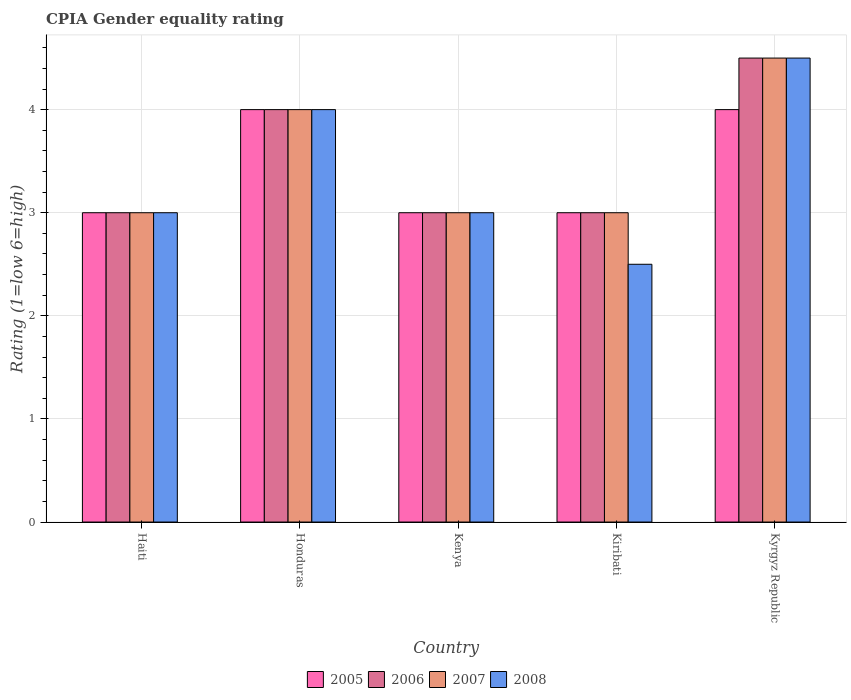Are the number of bars on each tick of the X-axis equal?
Your answer should be very brief. Yes. How many bars are there on the 2nd tick from the right?
Your answer should be very brief. 4. What is the label of the 4th group of bars from the left?
Your answer should be very brief. Kiribati. In how many cases, is the number of bars for a given country not equal to the number of legend labels?
Make the answer very short. 0. Across all countries, what is the maximum CPIA rating in 2006?
Offer a very short reply. 4.5. In which country was the CPIA rating in 2005 maximum?
Offer a very short reply. Honduras. In which country was the CPIA rating in 2008 minimum?
Your response must be concise. Kiribati. What is the difference between the CPIA rating in 2008 in Honduras and that in Kenya?
Make the answer very short. 1. In how many countries, is the CPIA rating in 2008 greater than 2?
Offer a terse response. 5. What is the ratio of the CPIA rating in 2007 in Kenya to that in Kyrgyz Republic?
Provide a succinct answer. 0.67. Is the CPIA rating in 2005 in Kenya less than that in Kyrgyz Republic?
Offer a very short reply. Yes. Is the difference between the CPIA rating in 2007 in Kenya and Kyrgyz Republic greater than the difference between the CPIA rating in 2005 in Kenya and Kyrgyz Republic?
Offer a terse response. No. What does the 2nd bar from the left in Kiribati represents?
Offer a terse response. 2006. What does the 1st bar from the right in Kiribati represents?
Offer a very short reply. 2008. Is it the case that in every country, the sum of the CPIA rating in 2007 and CPIA rating in 2008 is greater than the CPIA rating in 2006?
Your answer should be very brief. Yes. How many bars are there?
Your answer should be very brief. 20. Are all the bars in the graph horizontal?
Ensure brevity in your answer.  No. How many countries are there in the graph?
Offer a terse response. 5. Are the values on the major ticks of Y-axis written in scientific E-notation?
Offer a terse response. No. Does the graph contain any zero values?
Give a very brief answer. No. Does the graph contain grids?
Make the answer very short. Yes. Where does the legend appear in the graph?
Ensure brevity in your answer.  Bottom center. How are the legend labels stacked?
Make the answer very short. Horizontal. What is the title of the graph?
Make the answer very short. CPIA Gender equality rating. What is the label or title of the X-axis?
Make the answer very short. Country. What is the Rating (1=low 6=high) in 2005 in Haiti?
Your answer should be compact. 3. What is the Rating (1=low 6=high) of 2006 in Haiti?
Make the answer very short. 3. What is the Rating (1=low 6=high) of 2007 in Haiti?
Offer a very short reply. 3. What is the Rating (1=low 6=high) in 2008 in Haiti?
Ensure brevity in your answer.  3. What is the Rating (1=low 6=high) of 2005 in Honduras?
Give a very brief answer. 4. What is the Rating (1=low 6=high) of 2006 in Honduras?
Your response must be concise. 4. What is the Rating (1=low 6=high) of 2007 in Honduras?
Ensure brevity in your answer.  4. What is the Rating (1=low 6=high) of 2005 in Kenya?
Your answer should be compact. 3. What is the Rating (1=low 6=high) of 2008 in Kenya?
Your answer should be very brief. 3. What is the Rating (1=low 6=high) in 2006 in Kiribati?
Give a very brief answer. 3. What is the Rating (1=low 6=high) in 2008 in Kiribati?
Offer a terse response. 2.5. What is the Rating (1=low 6=high) in 2007 in Kyrgyz Republic?
Your answer should be very brief. 4.5. What is the Rating (1=low 6=high) of 2008 in Kyrgyz Republic?
Offer a terse response. 4.5. Across all countries, what is the maximum Rating (1=low 6=high) in 2005?
Provide a short and direct response. 4. Across all countries, what is the maximum Rating (1=low 6=high) in 2007?
Your answer should be compact. 4.5. Across all countries, what is the maximum Rating (1=low 6=high) of 2008?
Ensure brevity in your answer.  4.5. Across all countries, what is the minimum Rating (1=low 6=high) of 2005?
Offer a very short reply. 3. Across all countries, what is the minimum Rating (1=low 6=high) in 2008?
Provide a succinct answer. 2.5. What is the total Rating (1=low 6=high) in 2005 in the graph?
Your response must be concise. 17. What is the total Rating (1=low 6=high) in 2007 in the graph?
Make the answer very short. 17.5. What is the difference between the Rating (1=low 6=high) in 2006 in Haiti and that in Honduras?
Offer a terse response. -1. What is the difference between the Rating (1=low 6=high) of 2005 in Haiti and that in Kenya?
Your answer should be compact. 0. What is the difference between the Rating (1=low 6=high) of 2007 in Haiti and that in Kenya?
Ensure brevity in your answer.  0. What is the difference between the Rating (1=low 6=high) in 2008 in Haiti and that in Kenya?
Offer a terse response. 0. What is the difference between the Rating (1=low 6=high) of 2006 in Haiti and that in Kiribati?
Ensure brevity in your answer.  0. What is the difference between the Rating (1=low 6=high) of 2007 in Haiti and that in Kiribati?
Provide a short and direct response. 0. What is the difference between the Rating (1=low 6=high) in 2008 in Haiti and that in Kiribati?
Your response must be concise. 0.5. What is the difference between the Rating (1=low 6=high) in 2005 in Haiti and that in Kyrgyz Republic?
Your answer should be very brief. -1. What is the difference between the Rating (1=low 6=high) in 2005 in Honduras and that in Kenya?
Provide a short and direct response. 1. What is the difference between the Rating (1=low 6=high) in 2006 in Honduras and that in Kenya?
Your answer should be compact. 1. What is the difference between the Rating (1=low 6=high) of 2007 in Honduras and that in Kenya?
Your answer should be very brief. 1. What is the difference between the Rating (1=low 6=high) of 2008 in Honduras and that in Kenya?
Make the answer very short. 1. What is the difference between the Rating (1=low 6=high) in 2006 in Honduras and that in Kyrgyz Republic?
Offer a very short reply. -0.5. What is the difference between the Rating (1=low 6=high) of 2007 in Honduras and that in Kyrgyz Republic?
Your answer should be compact. -0.5. What is the difference between the Rating (1=low 6=high) of 2005 in Kenya and that in Kiribati?
Give a very brief answer. 0. What is the difference between the Rating (1=low 6=high) of 2008 in Kenya and that in Kiribati?
Provide a succinct answer. 0.5. What is the difference between the Rating (1=low 6=high) of 2007 in Kenya and that in Kyrgyz Republic?
Ensure brevity in your answer.  -1.5. What is the difference between the Rating (1=low 6=high) of 2005 in Haiti and the Rating (1=low 6=high) of 2007 in Honduras?
Ensure brevity in your answer.  -1. What is the difference between the Rating (1=low 6=high) of 2006 in Haiti and the Rating (1=low 6=high) of 2007 in Honduras?
Offer a very short reply. -1. What is the difference between the Rating (1=low 6=high) of 2007 in Haiti and the Rating (1=low 6=high) of 2008 in Honduras?
Provide a short and direct response. -1. What is the difference between the Rating (1=low 6=high) in 2005 in Haiti and the Rating (1=low 6=high) in 2006 in Kenya?
Provide a short and direct response. 0. What is the difference between the Rating (1=low 6=high) in 2006 in Haiti and the Rating (1=low 6=high) in 2008 in Kenya?
Provide a succinct answer. 0. What is the difference between the Rating (1=low 6=high) of 2007 in Haiti and the Rating (1=low 6=high) of 2008 in Kenya?
Your response must be concise. 0. What is the difference between the Rating (1=low 6=high) in 2005 in Haiti and the Rating (1=low 6=high) in 2006 in Kiribati?
Ensure brevity in your answer.  0. What is the difference between the Rating (1=low 6=high) in 2005 in Haiti and the Rating (1=low 6=high) in 2008 in Kiribati?
Provide a succinct answer. 0.5. What is the difference between the Rating (1=low 6=high) of 2007 in Haiti and the Rating (1=low 6=high) of 2008 in Kiribati?
Provide a succinct answer. 0.5. What is the difference between the Rating (1=low 6=high) in 2005 in Haiti and the Rating (1=low 6=high) in 2006 in Kyrgyz Republic?
Ensure brevity in your answer.  -1.5. What is the difference between the Rating (1=low 6=high) in 2005 in Haiti and the Rating (1=low 6=high) in 2007 in Kyrgyz Republic?
Ensure brevity in your answer.  -1.5. What is the difference between the Rating (1=low 6=high) of 2006 in Haiti and the Rating (1=low 6=high) of 2007 in Kyrgyz Republic?
Your answer should be very brief. -1.5. What is the difference between the Rating (1=low 6=high) in 2007 in Haiti and the Rating (1=low 6=high) in 2008 in Kyrgyz Republic?
Ensure brevity in your answer.  -1.5. What is the difference between the Rating (1=low 6=high) in 2005 in Honduras and the Rating (1=low 6=high) in 2007 in Kenya?
Make the answer very short. 1. What is the difference between the Rating (1=low 6=high) in 2006 in Honduras and the Rating (1=low 6=high) in 2007 in Kenya?
Ensure brevity in your answer.  1. What is the difference between the Rating (1=low 6=high) in 2007 in Honduras and the Rating (1=low 6=high) in 2008 in Kenya?
Give a very brief answer. 1. What is the difference between the Rating (1=low 6=high) in 2005 in Honduras and the Rating (1=low 6=high) in 2008 in Kiribati?
Make the answer very short. 1.5. What is the difference between the Rating (1=low 6=high) in 2006 in Honduras and the Rating (1=low 6=high) in 2007 in Kiribati?
Keep it short and to the point. 1. What is the difference between the Rating (1=low 6=high) of 2006 in Honduras and the Rating (1=low 6=high) of 2008 in Kiribati?
Your answer should be compact. 1.5. What is the difference between the Rating (1=low 6=high) of 2007 in Honduras and the Rating (1=low 6=high) of 2008 in Kiribati?
Offer a very short reply. 1.5. What is the difference between the Rating (1=low 6=high) in 2005 in Honduras and the Rating (1=low 6=high) in 2008 in Kyrgyz Republic?
Your answer should be compact. -0.5. What is the difference between the Rating (1=low 6=high) in 2006 in Honduras and the Rating (1=low 6=high) in 2008 in Kyrgyz Republic?
Your response must be concise. -0.5. What is the difference between the Rating (1=low 6=high) of 2005 in Kenya and the Rating (1=low 6=high) of 2006 in Kiribati?
Ensure brevity in your answer.  0. What is the difference between the Rating (1=low 6=high) in 2005 in Kenya and the Rating (1=low 6=high) in 2008 in Kiribati?
Give a very brief answer. 0.5. What is the difference between the Rating (1=low 6=high) of 2005 in Kenya and the Rating (1=low 6=high) of 2007 in Kyrgyz Republic?
Provide a short and direct response. -1.5. What is the difference between the Rating (1=low 6=high) of 2005 in Kenya and the Rating (1=low 6=high) of 2008 in Kyrgyz Republic?
Offer a terse response. -1.5. What is the difference between the Rating (1=low 6=high) in 2006 in Kenya and the Rating (1=low 6=high) in 2007 in Kyrgyz Republic?
Ensure brevity in your answer.  -1.5. What is the difference between the Rating (1=low 6=high) in 2006 in Kenya and the Rating (1=low 6=high) in 2008 in Kyrgyz Republic?
Make the answer very short. -1.5. What is the difference between the Rating (1=low 6=high) of 2007 in Kenya and the Rating (1=low 6=high) of 2008 in Kyrgyz Republic?
Your response must be concise. -1.5. What is the difference between the Rating (1=low 6=high) in 2005 in Kiribati and the Rating (1=low 6=high) in 2006 in Kyrgyz Republic?
Your answer should be very brief. -1.5. What is the difference between the Rating (1=low 6=high) of 2005 in Kiribati and the Rating (1=low 6=high) of 2007 in Kyrgyz Republic?
Keep it short and to the point. -1.5. What is the difference between the Rating (1=low 6=high) of 2005 in Kiribati and the Rating (1=low 6=high) of 2008 in Kyrgyz Republic?
Keep it short and to the point. -1.5. What is the difference between the Rating (1=low 6=high) in 2006 in Kiribati and the Rating (1=low 6=high) in 2007 in Kyrgyz Republic?
Provide a succinct answer. -1.5. What is the difference between the Rating (1=low 6=high) of 2007 in Kiribati and the Rating (1=low 6=high) of 2008 in Kyrgyz Republic?
Your response must be concise. -1.5. What is the average Rating (1=low 6=high) of 2007 per country?
Offer a terse response. 3.5. What is the difference between the Rating (1=low 6=high) in 2005 and Rating (1=low 6=high) in 2007 in Haiti?
Offer a terse response. 0. What is the difference between the Rating (1=low 6=high) in 2005 and Rating (1=low 6=high) in 2008 in Haiti?
Make the answer very short. 0. What is the difference between the Rating (1=low 6=high) of 2006 and Rating (1=low 6=high) of 2007 in Haiti?
Offer a terse response. 0. What is the difference between the Rating (1=low 6=high) in 2006 and Rating (1=low 6=high) in 2008 in Haiti?
Keep it short and to the point. 0. What is the difference between the Rating (1=low 6=high) of 2007 and Rating (1=low 6=high) of 2008 in Haiti?
Your answer should be compact. 0. What is the difference between the Rating (1=low 6=high) of 2005 and Rating (1=low 6=high) of 2006 in Honduras?
Keep it short and to the point. 0. What is the difference between the Rating (1=low 6=high) of 2005 and Rating (1=low 6=high) of 2007 in Honduras?
Give a very brief answer. 0. What is the difference between the Rating (1=low 6=high) in 2005 and Rating (1=low 6=high) in 2008 in Honduras?
Your answer should be compact. 0. What is the difference between the Rating (1=low 6=high) of 2006 and Rating (1=low 6=high) of 2008 in Honduras?
Keep it short and to the point. 0. What is the difference between the Rating (1=low 6=high) in 2005 and Rating (1=low 6=high) in 2006 in Kenya?
Offer a very short reply. 0. What is the difference between the Rating (1=low 6=high) of 2005 and Rating (1=low 6=high) of 2007 in Kenya?
Make the answer very short. 0. What is the difference between the Rating (1=low 6=high) of 2006 and Rating (1=low 6=high) of 2008 in Kenya?
Give a very brief answer. 0. What is the difference between the Rating (1=low 6=high) in 2007 and Rating (1=low 6=high) in 2008 in Kiribati?
Give a very brief answer. 0.5. What is the difference between the Rating (1=low 6=high) in 2005 and Rating (1=low 6=high) in 2006 in Kyrgyz Republic?
Give a very brief answer. -0.5. What is the difference between the Rating (1=low 6=high) of 2006 and Rating (1=low 6=high) of 2007 in Kyrgyz Republic?
Provide a succinct answer. 0. What is the ratio of the Rating (1=low 6=high) of 2008 in Haiti to that in Honduras?
Provide a short and direct response. 0.75. What is the ratio of the Rating (1=low 6=high) in 2006 in Haiti to that in Kenya?
Offer a terse response. 1. What is the ratio of the Rating (1=low 6=high) of 2007 in Haiti to that in Kyrgyz Republic?
Provide a succinct answer. 0.67. What is the ratio of the Rating (1=low 6=high) in 2008 in Haiti to that in Kyrgyz Republic?
Offer a very short reply. 0.67. What is the ratio of the Rating (1=low 6=high) in 2005 in Honduras to that in Kenya?
Your response must be concise. 1.33. What is the ratio of the Rating (1=low 6=high) in 2006 in Honduras to that in Kenya?
Keep it short and to the point. 1.33. What is the ratio of the Rating (1=low 6=high) of 2008 in Honduras to that in Kenya?
Make the answer very short. 1.33. What is the ratio of the Rating (1=low 6=high) in 2008 in Honduras to that in Kiribati?
Keep it short and to the point. 1.6. What is the ratio of the Rating (1=low 6=high) in 2005 in Honduras to that in Kyrgyz Republic?
Your response must be concise. 1. What is the ratio of the Rating (1=low 6=high) in 2008 in Honduras to that in Kyrgyz Republic?
Provide a succinct answer. 0.89. What is the ratio of the Rating (1=low 6=high) in 2007 in Kenya to that in Kiribati?
Your answer should be compact. 1. What is the ratio of the Rating (1=low 6=high) in 2008 in Kenya to that in Kiribati?
Your answer should be very brief. 1.2. What is the ratio of the Rating (1=low 6=high) in 2006 in Kenya to that in Kyrgyz Republic?
Provide a short and direct response. 0.67. What is the ratio of the Rating (1=low 6=high) in 2007 in Kenya to that in Kyrgyz Republic?
Offer a very short reply. 0.67. What is the ratio of the Rating (1=low 6=high) of 2008 in Kenya to that in Kyrgyz Republic?
Make the answer very short. 0.67. What is the ratio of the Rating (1=low 6=high) of 2005 in Kiribati to that in Kyrgyz Republic?
Provide a succinct answer. 0.75. What is the ratio of the Rating (1=low 6=high) of 2006 in Kiribati to that in Kyrgyz Republic?
Keep it short and to the point. 0.67. What is the ratio of the Rating (1=low 6=high) in 2008 in Kiribati to that in Kyrgyz Republic?
Provide a succinct answer. 0.56. What is the difference between the highest and the lowest Rating (1=low 6=high) of 2006?
Offer a very short reply. 1.5. What is the difference between the highest and the lowest Rating (1=low 6=high) in 2008?
Make the answer very short. 2. 